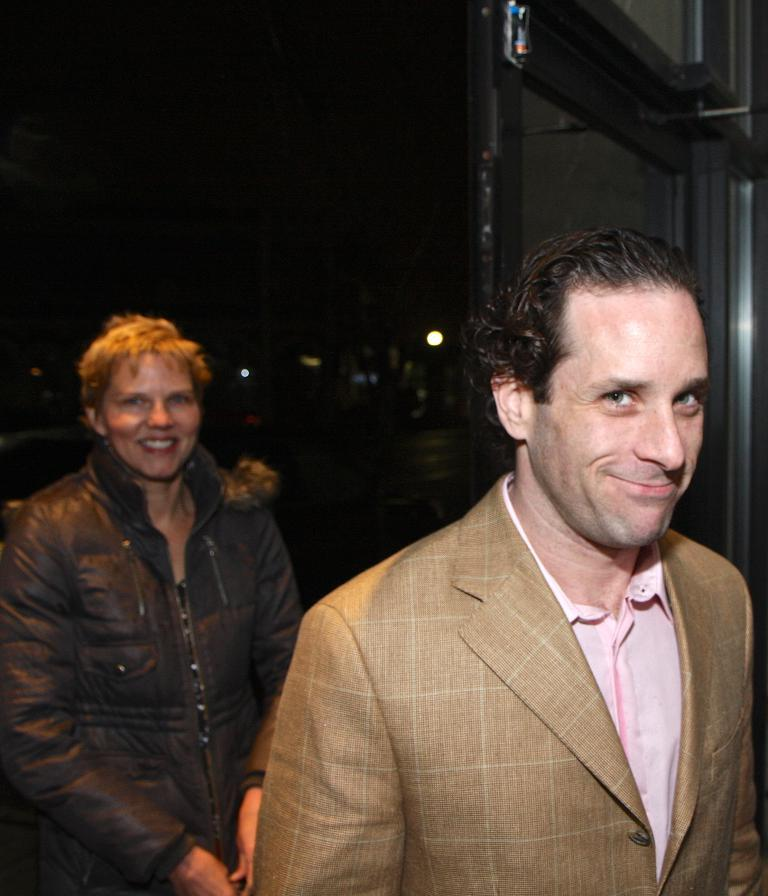How many people are in the image? There are two people in the image. What are the people doing in the image? The people are standing and smiling. What can be seen in the background of the image? There is a wall and lights visible in the background. What is the people pointing at in the image? There is no indication in the image that the people are pointing at anything. 